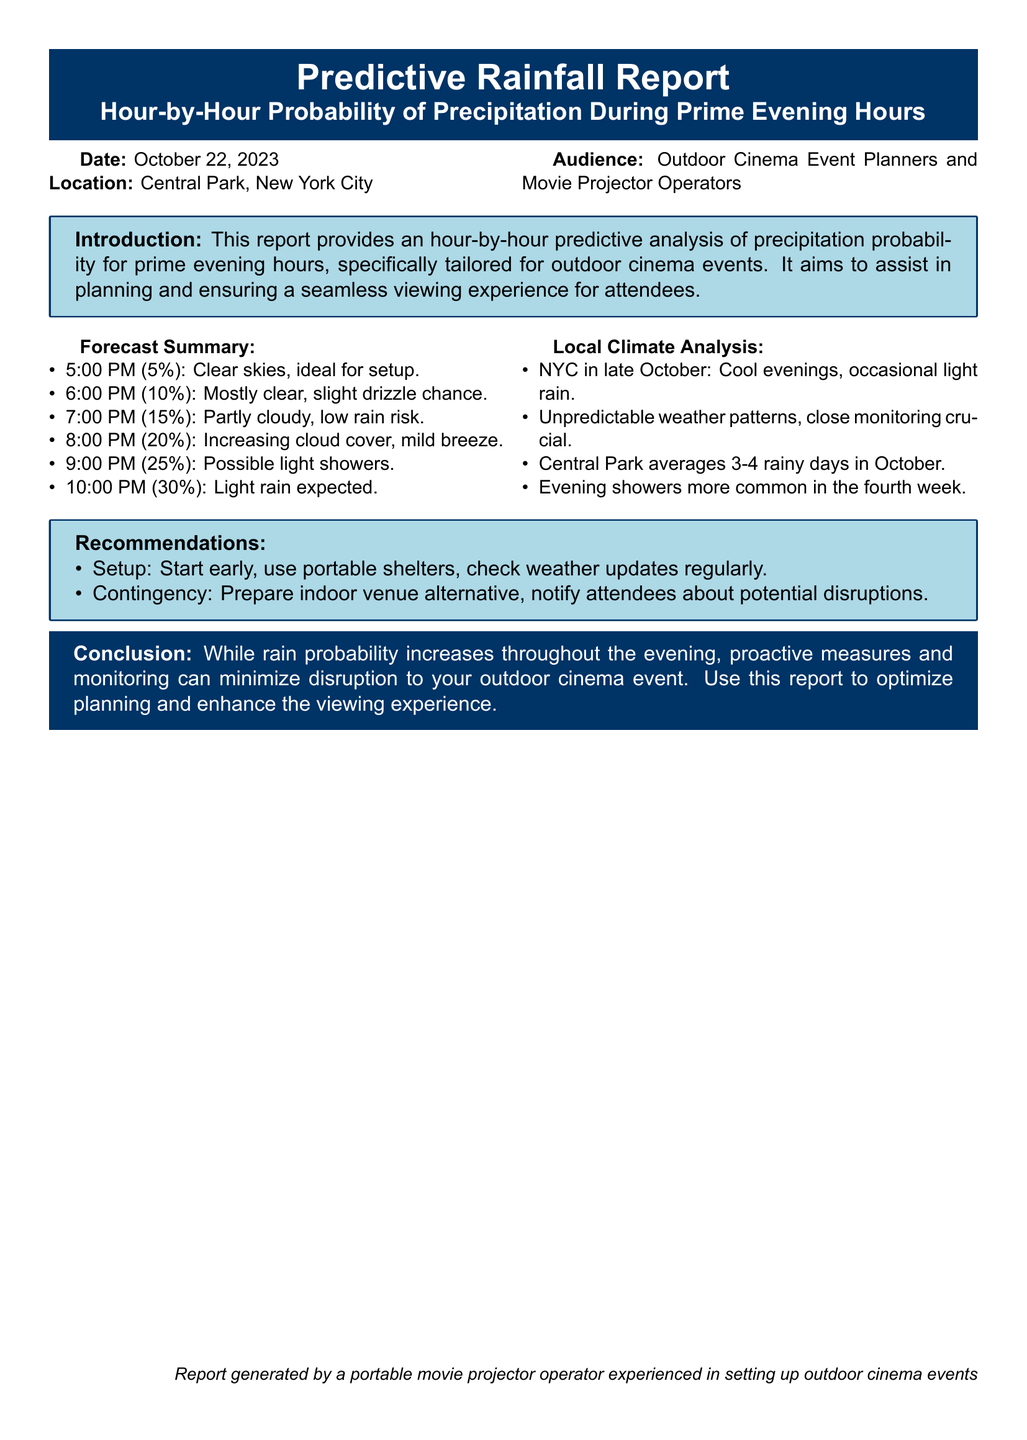What is the date of the report? The report specifically states the date of the predictive rainfall report, which is October 22, 2023.
Answer: October 22, 2023 What is the location of the outdoor cinema event? The document mentions that the location for the event is Central Park, New York City.
Answer: Central Park, New York City What is the highest probability of precipitation during the evening? The report indicates a 30% chance of light rain expected at 10:00 PM, which is the highest probability listed.
Answer: 30% What time has the lowest probability of precipitation? According to the forecast summary, 5:00 PM has a 5% chance, which is the lowest probability of precipitation during the evening hours.
Answer: 5:00 PM What is suggested for setup? The recommendations section advises to start early and use portable shelters for event setup to mitigate potential weather impacts.
Answer: Start early, use portable shelters What characterizes NYC's weather in late October? The local climate analysis describes NYC in late October as having cool evenings with occasional light rain, highlighting the area's typical weather patterns.
Answer: Cool evenings, occasional light rain What percentage chance of rain is indicated for 6:00 PM? The report specifically indicates a 10% chance of rain for the hour of 6:00 PM.
Answer: 10% What should event planners prepare for according to the contingency plan? The recommendations include preparing an indoor venue alternative as a key part of the contingency plan for potential rain disruptions.
Answer: Indoor venue alternative 